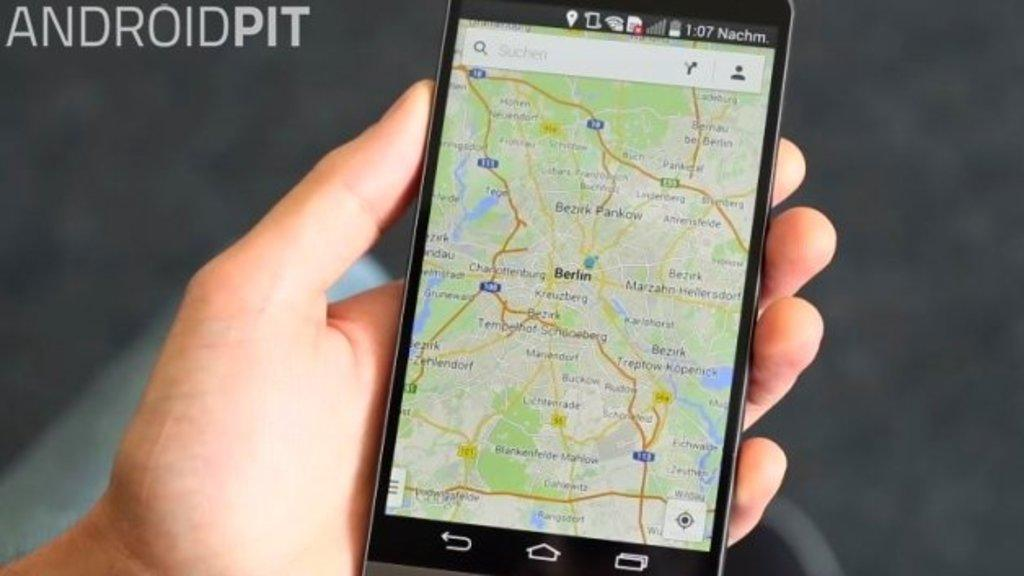<image>
Give a short and clear explanation of the subsequent image. The GPS is showing the roads that lead into Berlin. 